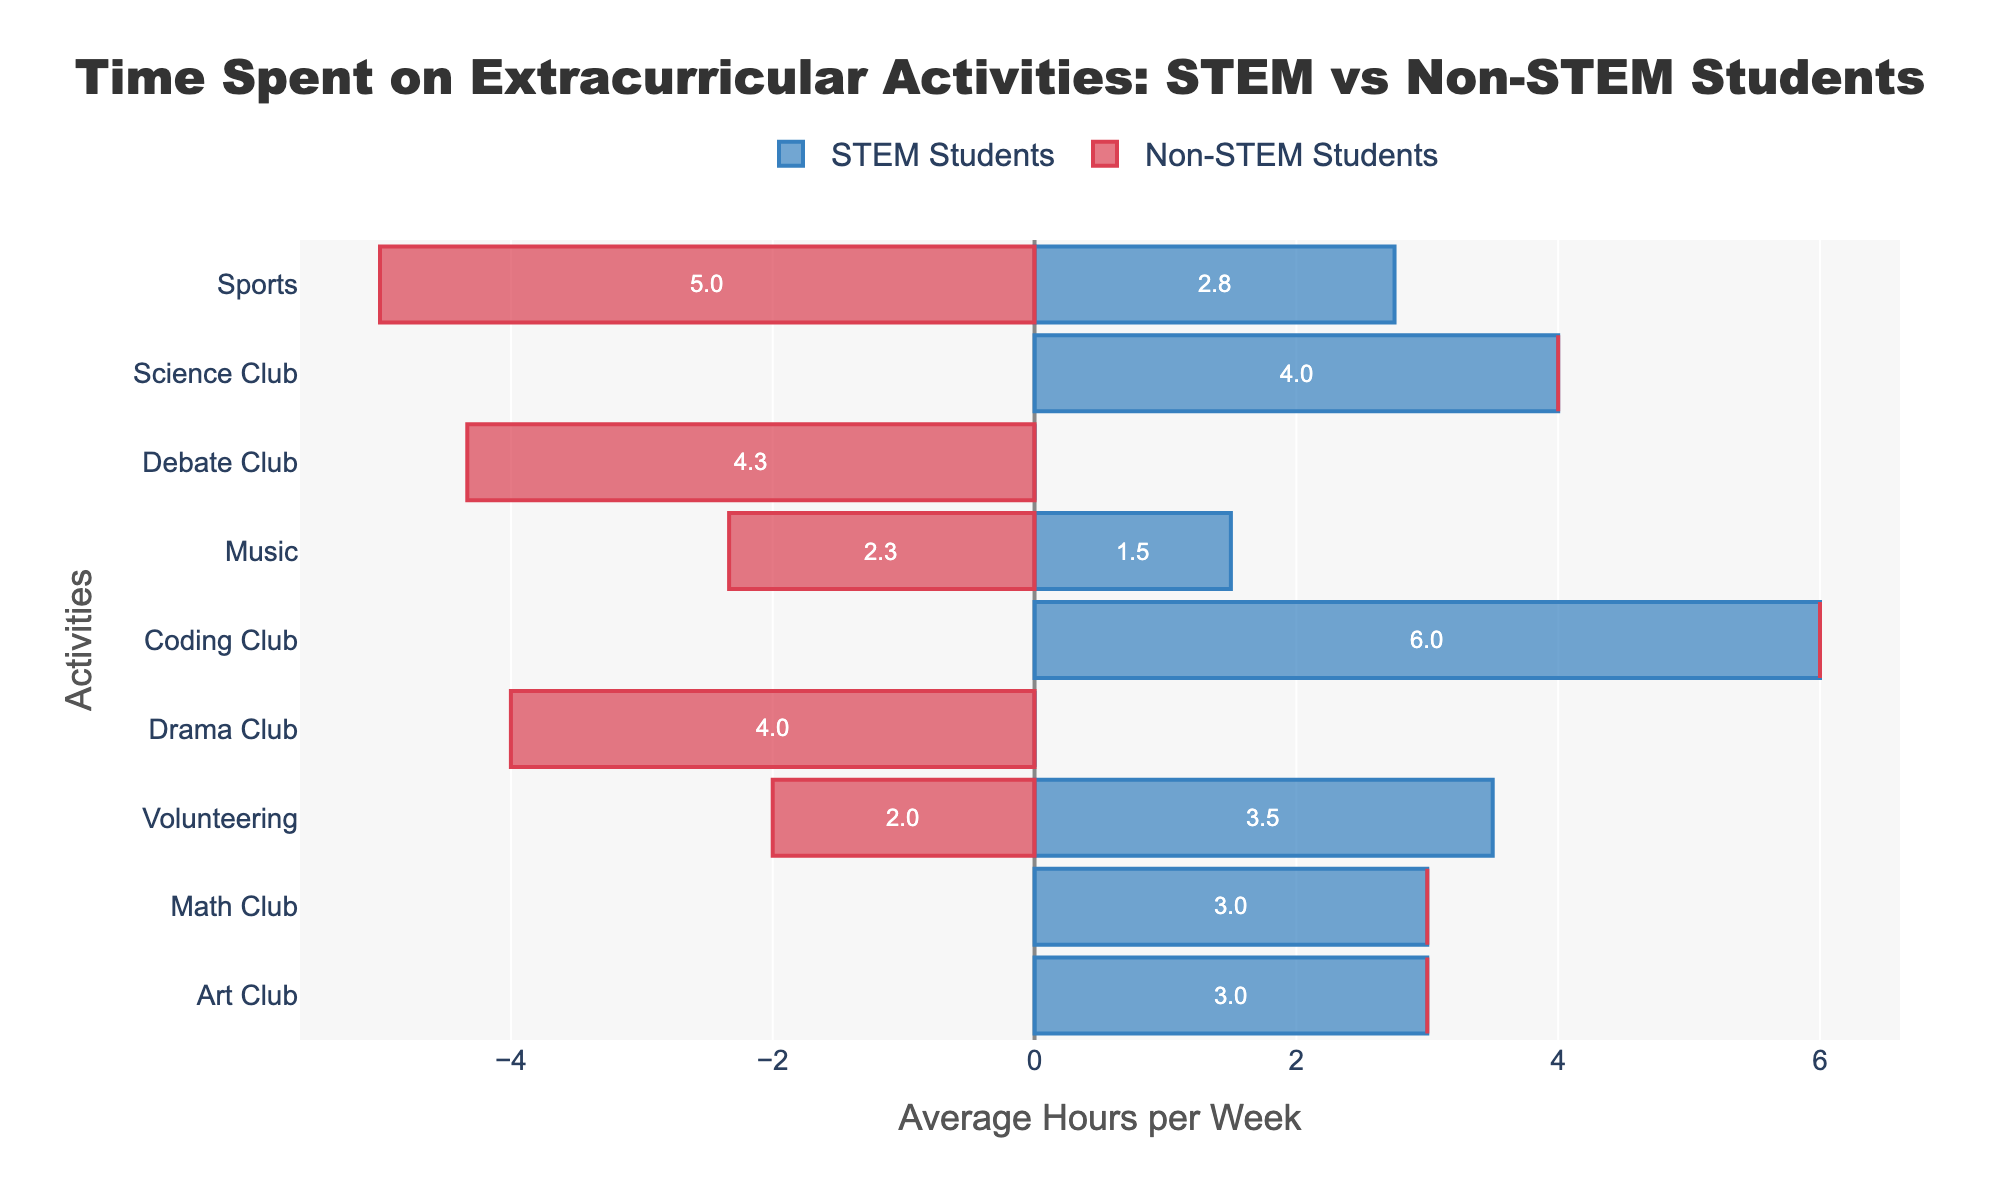What activity do STEM students spend the most time on? Look for the tallest blue bar that represents STEM students. The tallest blue bar corresponds to the Coding Club, which means STEM students spend the highest average number of hours per week on this activity.
Answer: Coding Club Do Non-STEM students spend more time on sports or volunteering? Compare the height of the red bars for Sports and Volunteering. The red bar for Sports is longer than the bar for Volunteering, indicating that Non-STEM students spend more time on sports.
Answer: Sports Which activities have both STEM and Non-STEM students participating in them? Identify activities where both blue and red bars are present. The activities with both types of students are Sports, Music, Volunteering, Debate Club, and Art Club.
Answer: Sports, Music, Volunteering, Debate Club, Art Club How many hours per week do Non-STEM students spend more on Drama Club compared to STEM students? The red bar for Drama Club (Non-STEM) is at 4 hours (-4 on the chart), and there is no blue bar for Drama Club, meaning STEM students spend 0 hours. Therefore, Non-STEM students spend 4 hours more on Drama Club.
Answer: 4 hours What is the total average number of hours per week that students (both STEM and Non-STEM) spend on Music? Add the absolute values of the average hours for STEM (1 hour) and Non-STEM (3 hours) students in Music. The total is 1 + 3 = 4 hours per week.
Answer: 4 hours Do STEM students spend more time on Math Club or Science Club on average? Compare the height of the blue bars representing Math Club and Science Club. The bar for Science Club is taller than that for Math Club, indicating STEM students spend more time on Science Club.
Answer: Science Club Which type of students spends more time on Debate Club, and by how much? Compare the length of the blue and red bars for Debate Club. The red bar (-6) is longer than the blue bar (2), indicating Non-STEM students spend more time. The difference is 6 - 2 = 4 hours.
Answer: Non-STEM by 4 hours How many more hours per week do STEM students spend on Coding Club compared to Debating Club? The average hours for Coding Club is 6 (positive direction) and for Debating Club is 2 (positive direction as well). The difference is 6 - 2 = 4 hours.
Answer: 4 hours What is the average number of hours per week spent by STEM students on Art Club, Music, and Volunteering? Add the average hours for Art Club (4), Music (1), and Volunteering (4). Then, calculate the mean: (4 + 1 + 4) / 3 = 3 hours/week.
Answer: 3 hours/week 